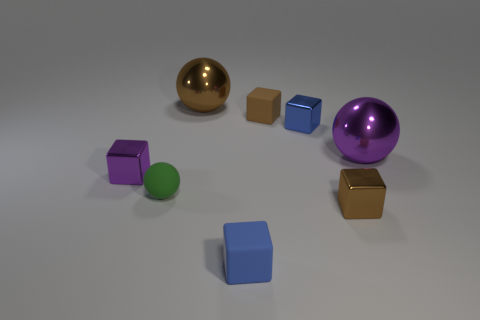Are there any large objects that have the same material as the tiny purple thing?
Offer a very short reply. Yes. What material is the cube on the left side of the large object that is on the left side of the big purple thing?
Offer a terse response. Metal. What size is the brown block behind the tiny green matte sphere?
Give a very brief answer. Small. Does the green ball have the same material as the small brown object behind the large purple object?
Your answer should be compact. Yes. How many small objects are blue things or cylinders?
Offer a terse response. 2. Is the number of small things less than the number of things?
Ensure brevity in your answer.  Yes. There is a metallic block that is to the left of the tiny brown matte block; is its size the same as the rubber block in front of the tiny blue shiny thing?
Offer a very short reply. Yes. What number of cyan things are large blocks or metal cubes?
Your answer should be very brief. 0. Are there more purple things than small rubber objects?
Give a very brief answer. No. What number of objects are either green things or metal things behind the large purple metal object?
Provide a succinct answer. 3. 